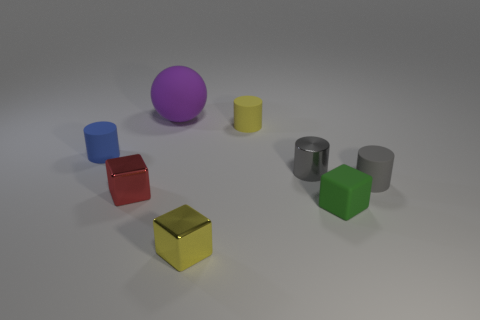Add 1 small cubes. How many objects exist? 9 Subtract all spheres. How many objects are left? 7 Add 6 large green metallic spheres. How many large green metallic spheres exist? 6 Subtract 0 red spheres. How many objects are left? 8 Subtract all large spheres. Subtract all small yellow shiny blocks. How many objects are left? 6 Add 2 small yellow rubber cylinders. How many small yellow rubber cylinders are left? 3 